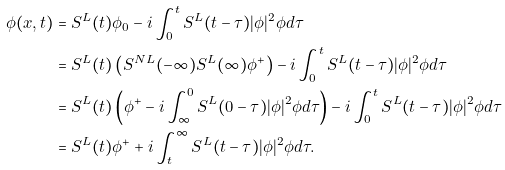<formula> <loc_0><loc_0><loc_500><loc_500>\phi ( x , t ) & = S ^ { L } ( t ) \phi _ { 0 } - i \int _ { 0 } ^ { t } S ^ { L } ( t - \tau ) | \phi | ^ { 2 } \phi d \tau \\ & = S ^ { L } ( t ) \left ( S ^ { N L } ( - \infty ) S ^ { L } ( \infty ) \phi ^ { + } \right ) - i \int _ { 0 } ^ { t } S ^ { L } ( t - \tau ) | \phi | ^ { 2 } \phi d \tau \\ & = S ^ { L } ( t ) \left ( \phi ^ { + } - i \int _ { \infty } ^ { 0 } S ^ { L } ( 0 - \tau ) | \phi | ^ { 2 } \phi d \tau \right ) - i \int _ { 0 } ^ { t } S ^ { L } ( t - \tau ) | \phi | ^ { 2 } \phi d \tau \\ & = S ^ { L } ( t ) \phi ^ { + } + i \int _ { t } ^ { \infty } S ^ { L } ( t - \tau ) | \phi | ^ { 2 } \phi d \tau .</formula> 